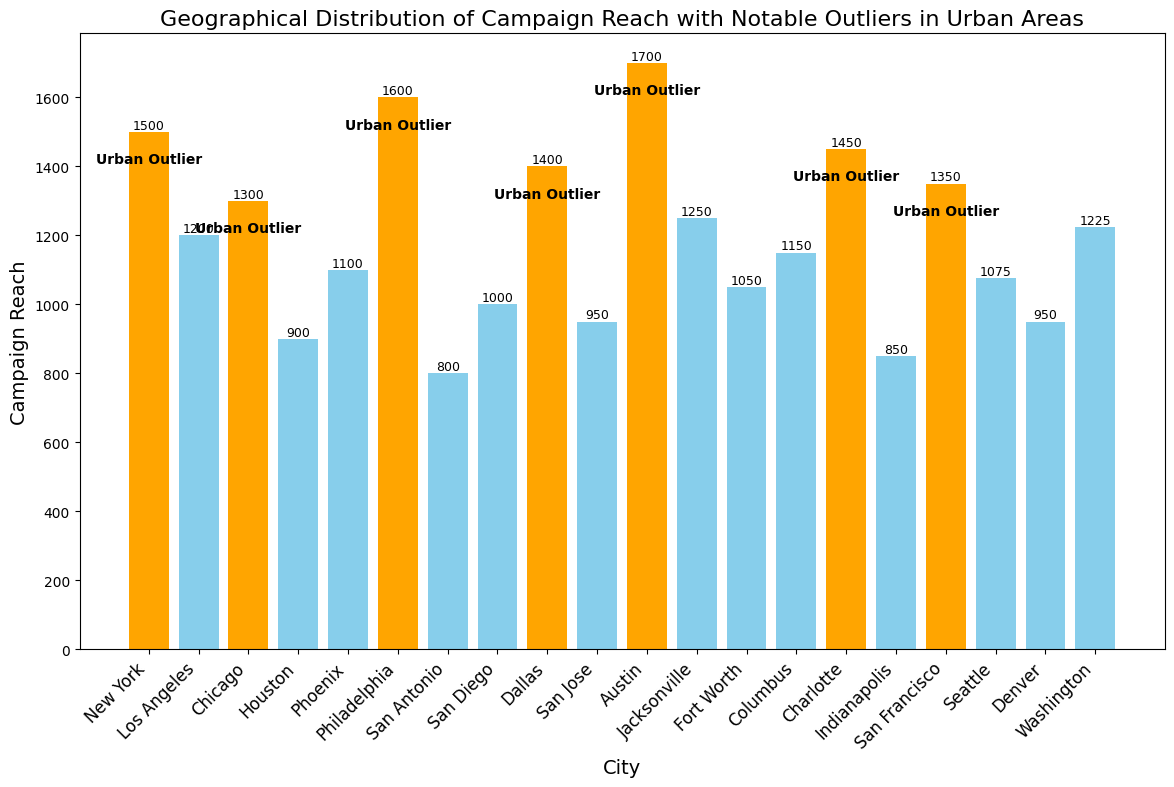What's the city with the highest campaign reach? The highest bar indicates the city with the highest campaign reach, which is Austin with a reach of 1700.
Answer: Austin What is the total campaign reach for the cities marked as urban outliers? The urban outliers are New York (1500), Chicago (1300), Philadelphia (1600), Dallas (1400), Austin (1700), Charlotte (1450), and San Francisco (1350). Adding these values: 1500 + 1300 + 1600 + 1400 + 1700 + 1450 + 1350 = 9300.
Answer: 9300 Which city with the lowest campaign reach is an urban outlier? Among the bars marked as urban outliers, the shortest belongs to Chicago, with a campaign reach of 1300.
Answer: Chicago What is the difference in campaign reach between Philadelphia and Dallas? Philadelphia has a reach of 1600, and Dallas has a reach of 1400. The difference is 1600 - 1400 = 200.
Answer: 200 Which city with a campaign reach of more than 1000 is not an urban outlier? Cities with a campaign reach above 1000 are Los Angeles, Houston, Phoenix, San Diego, Jacksonville, Fort Worth, Columbus, San Jose, Seattle, and Washington. Among these, Los Angeles has a reach of 1200 and is not an urban outlier.
Answer: Los Angeles How many cities have a campaign reach between 900 and 1100 inclusive? The bars indicating cities with a campaign reach between 900 and 1100 inclusive are Houston (900), Phoenix (1100), San Diego (1000), Fort Worth (1050), and Columbus (1150). This totals five cities.
Answer: 5 Which outlier city has the highest campaign reach among urban outliers, and what is the reach? The highest campaign reach among urban outliers is Austin, with a reach of 1700.
Answer: Austin Is San Antonio an urban outlier? The bar for San Antonio is not marked with the "Urban Outlier" annotation.
Answer: No What is the average campaign reach of non-urban outlier cities? Non-urban outlier cities are Los Angeles (1200), Houston (900), Phoenix (1100), San Antonio (800), San Diego (1000), San Jose (950), Jacksonville (1250), Fort Worth (1050), Columbus (1150), Seattle (1075), Denver (950), and Washington (1225). The total is 1200 + 900 + 1100 + 800 + 1000 + 950 + 1250 + 1050 + 1150 + 1075 + 950 + 1225 = 13650. The average, therefore, is 13650 / 12 ≈ 1138.
Answer: 1138 